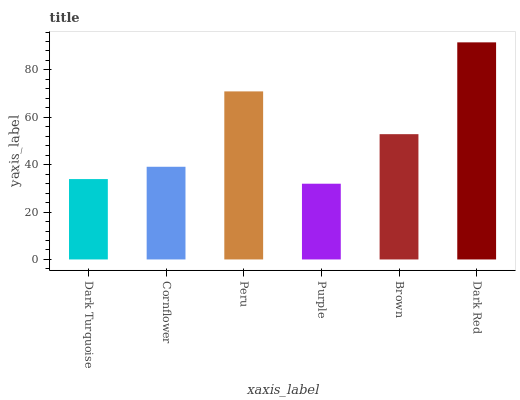Is Purple the minimum?
Answer yes or no. Yes. Is Dark Red the maximum?
Answer yes or no. Yes. Is Cornflower the minimum?
Answer yes or no. No. Is Cornflower the maximum?
Answer yes or no. No. Is Cornflower greater than Dark Turquoise?
Answer yes or no. Yes. Is Dark Turquoise less than Cornflower?
Answer yes or no. Yes. Is Dark Turquoise greater than Cornflower?
Answer yes or no. No. Is Cornflower less than Dark Turquoise?
Answer yes or no. No. Is Brown the high median?
Answer yes or no. Yes. Is Cornflower the low median?
Answer yes or no. Yes. Is Dark Turquoise the high median?
Answer yes or no. No. Is Purple the low median?
Answer yes or no. No. 